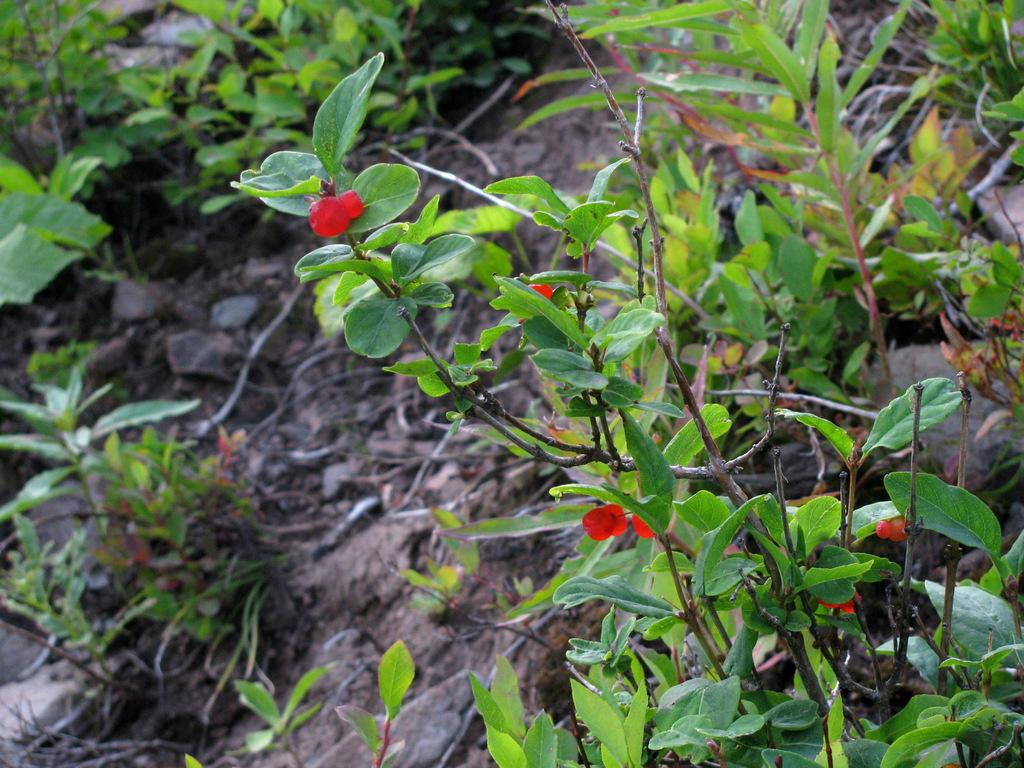What type of living organisms can be seen in the image? Flowers and plants are visible in the image. What is the surface on which the flowers and plants are placed? The flowers and plants are on a surface. What songs are the giants singing in the image? There are no giants or songs present in the image; it features flowers and plants on a surface. 